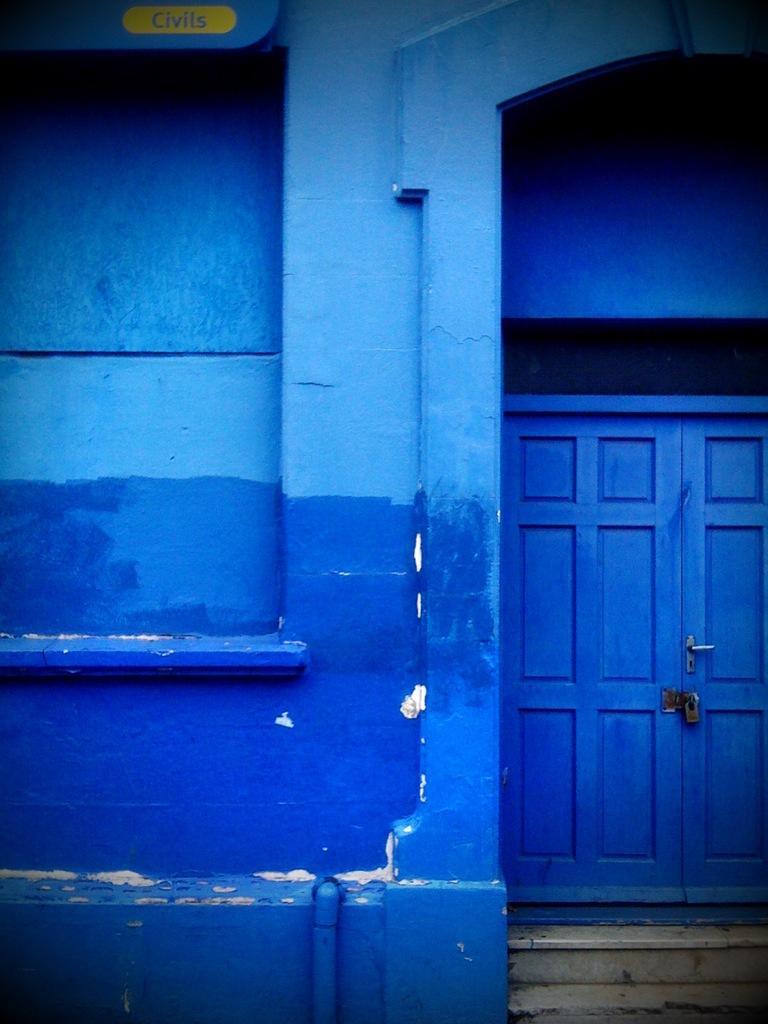Please provide a concise description of this image. In this image there is a locked wooden door, beside the door there is a wall. 